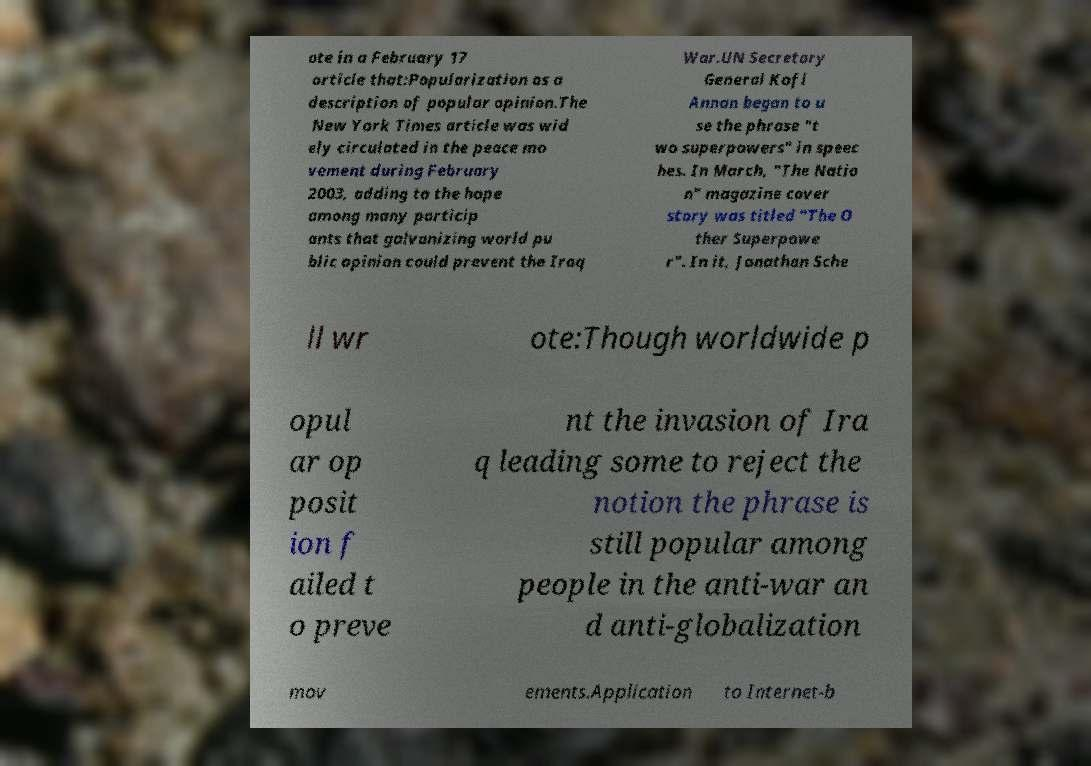Can you read and provide the text displayed in the image?This photo seems to have some interesting text. Can you extract and type it out for me? ote in a February 17 article that:Popularization as a description of popular opinion.The New York Times article was wid ely circulated in the peace mo vement during February 2003, adding to the hope among many particip ants that galvanizing world pu blic opinion could prevent the Iraq War.UN Secretary General Kofi Annan began to u se the phrase "t wo superpowers" in speec hes. In March, "The Natio n" magazine cover story was titled "The O ther Superpowe r". In it, Jonathan Sche ll wr ote:Though worldwide p opul ar op posit ion f ailed t o preve nt the invasion of Ira q leading some to reject the notion the phrase is still popular among people in the anti-war an d anti-globalization mov ements.Application to Internet-b 